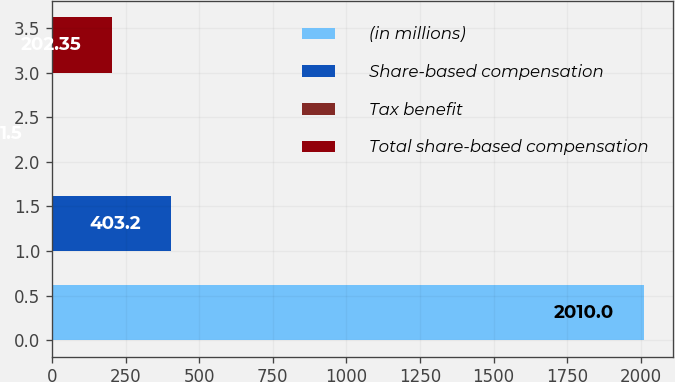<chart> <loc_0><loc_0><loc_500><loc_500><bar_chart><fcel>(in millions)<fcel>Share-based compensation<fcel>Tax benefit<fcel>Total share-based compensation<nl><fcel>2010<fcel>403.2<fcel>1.5<fcel>202.35<nl></chart> 